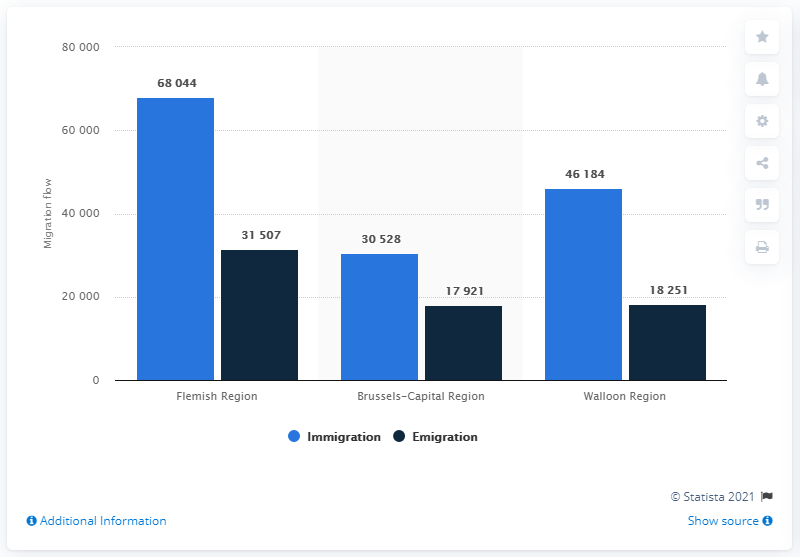Outline some significant characteristics in this image. In 2019, it is estimated that a total of 30,528 individuals migrated to the city of Brussels. The Flemish Region has the highest difference between immigration and emigration, indicating a significant influx of people into the region. The Flemish Region has the highest level of migration flow. In 2019, a total of 17,921 individuals migrated from Brussels. 